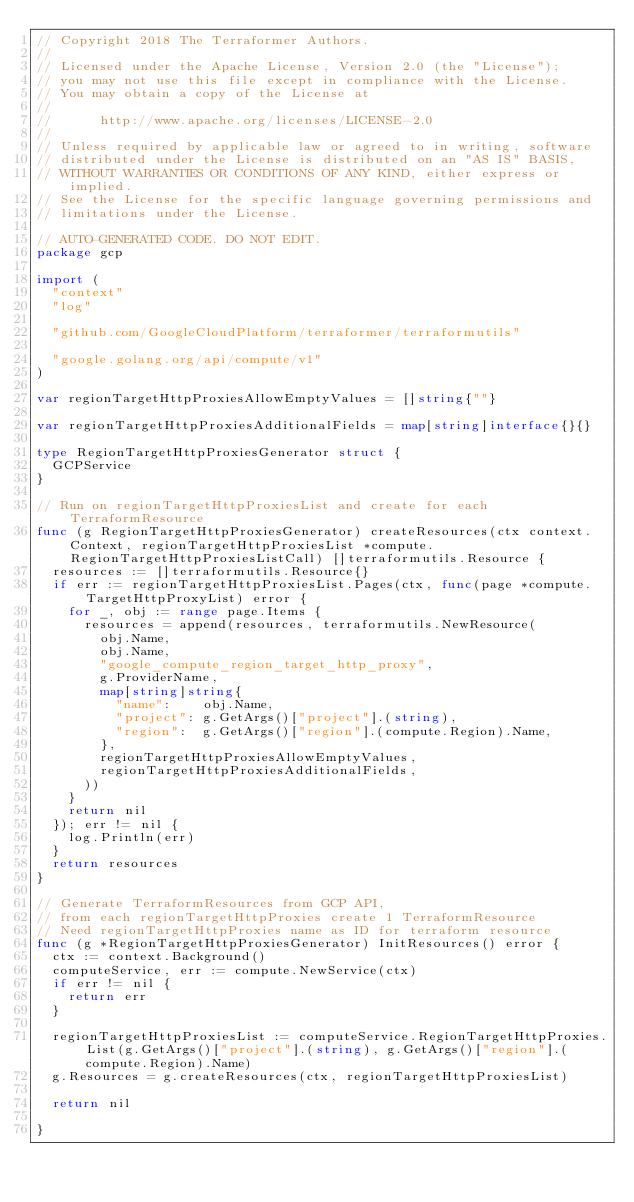Convert code to text. <code><loc_0><loc_0><loc_500><loc_500><_Go_>// Copyright 2018 The Terraformer Authors.
//
// Licensed under the Apache License, Version 2.0 (the "License");
// you may not use this file except in compliance with the License.
// You may obtain a copy of the License at
//
//      http://www.apache.org/licenses/LICENSE-2.0
//
// Unless required by applicable law or agreed to in writing, software
// distributed under the License is distributed on an "AS IS" BASIS,
// WITHOUT WARRANTIES OR CONDITIONS OF ANY KIND, either express or implied.
// See the License for the specific language governing permissions and
// limitations under the License.

// AUTO-GENERATED CODE. DO NOT EDIT.
package gcp

import (
	"context"
	"log"

	"github.com/GoogleCloudPlatform/terraformer/terraformutils"

	"google.golang.org/api/compute/v1"
)

var regionTargetHttpProxiesAllowEmptyValues = []string{""}

var regionTargetHttpProxiesAdditionalFields = map[string]interface{}{}

type RegionTargetHttpProxiesGenerator struct {
	GCPService
}

// Run on regionTargetHttpProxiesList and create for each TerraformResource
func (g RegionTargetHttpProxiesGenerator) createResources(ctx context.Context, regionTargetHttpProxiesList *compute.RegionTargetHttpProxiesListCall) []terraformutils.Resource {
	resources := []terraformutils.Resource{}
	if err := regionTargetHttpProxiesList.Pages(ctx, func(page *compute.TargetHttpProxyList) error {
		for _, obj := range page.Items {
			resources = append(resources, terraformutils.NewResource(
				obj.Name,
				obj.Name,
				"google_compute_region_target_http_proxy",
				g.ProviderName,
				map[string]string{
					"name":    obj.Name,
					"project": g.GetArgs()["project"].(string),
					"region":  g.GetArgs()["region"].(compute.Region).Name,
				},
				regionTargetHttpProxiesAllowEmptyValues,
				regionTargetHttpProxiesAdditionalFields,
			))
		}
		return nil
	}); err != nil {
		log.Println(err)
	}
	return resources
}

// Generate TerraformResources from GCP API,
// from each regionTargetHttpProxies create 1 TerraformResource
// Need regionTargetHttpProxies name as ID for terraform resource
func (g *RegionTargetHttpProxiesGenerator) InitResources() error {
	ctx := context.Background()
	computeService, err := compute.NewService(ctx)
	if err != nil {
		return err
	}

	regionTargetHttpProxiesList := computeService.RegionTargetHttpProxies.List(g.GetArgs()["project"].(string), g.GetArgs()["region"].(compute.Region).Name)
	g.Resources = g.createResources(ctx, regionTargetHttpProxiesList)

	return nil

}
</code> 